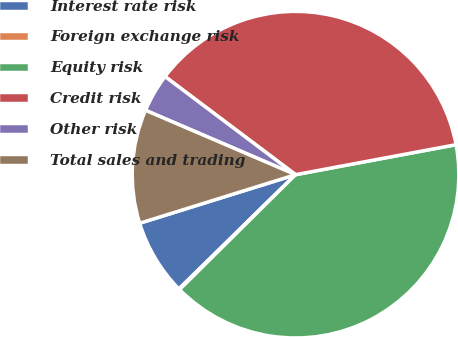Convert chart to OTSL. <chart><loc_0><loc_0><loc_500><loc_500><pie_chart><fcel>Interest rate risk<fcel>Foreign exchange risk<fcel>Equity risk<fcel>Credit risk<fcel>Other risk<fcel>Total sales and trading<nl><fcel>7.53%<fcel>0.09%<fcel>40.52%<fcel>36.8%<fcel>3.81%<fcel>11.26%<nl></chart> 